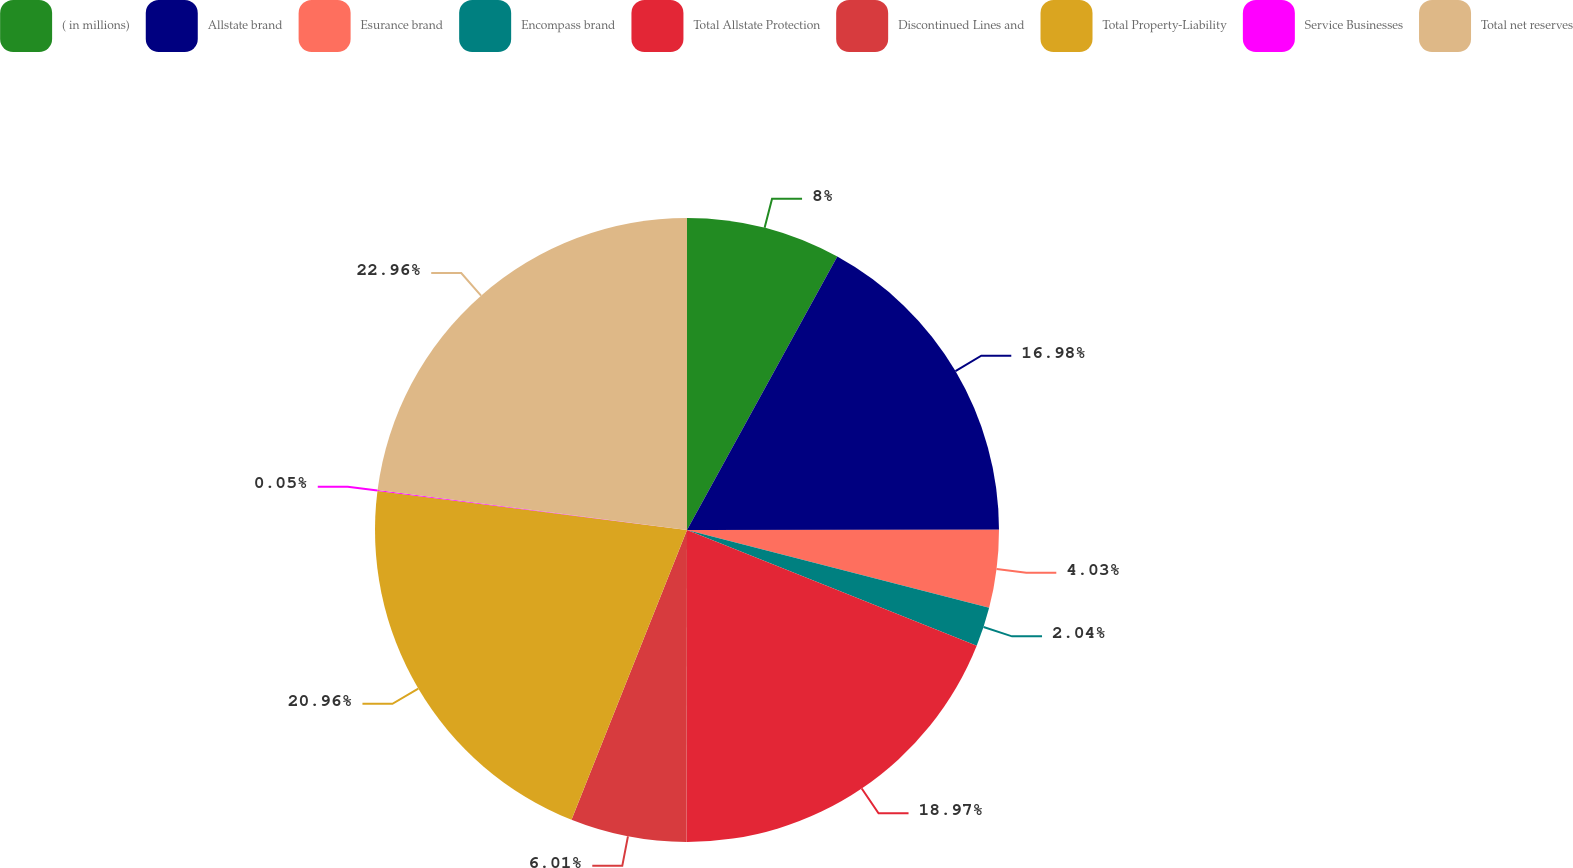Convert chart to OTSL. <chart><loc_0><loc_0><loc_500><loc_500><pie_chart><fcel>( in millions)<fcel>Allstate brand<fcel>Esurance brand<fcel>Encompass brand<fcel>Total Allstate Protection<fcel>Discontinued Lines and<fcel>Total Property-Liability<fcel>Service Businesses<fcel>Total net reserves<nl><fcel>8.0%<fcel>16.98%<fcel>4.03%<fcel>2.04%<fcel>18.97%<fcel>6.01%<fcel>20.96%<fcel>0.05%<fcel>22.95%<nl></chart> 